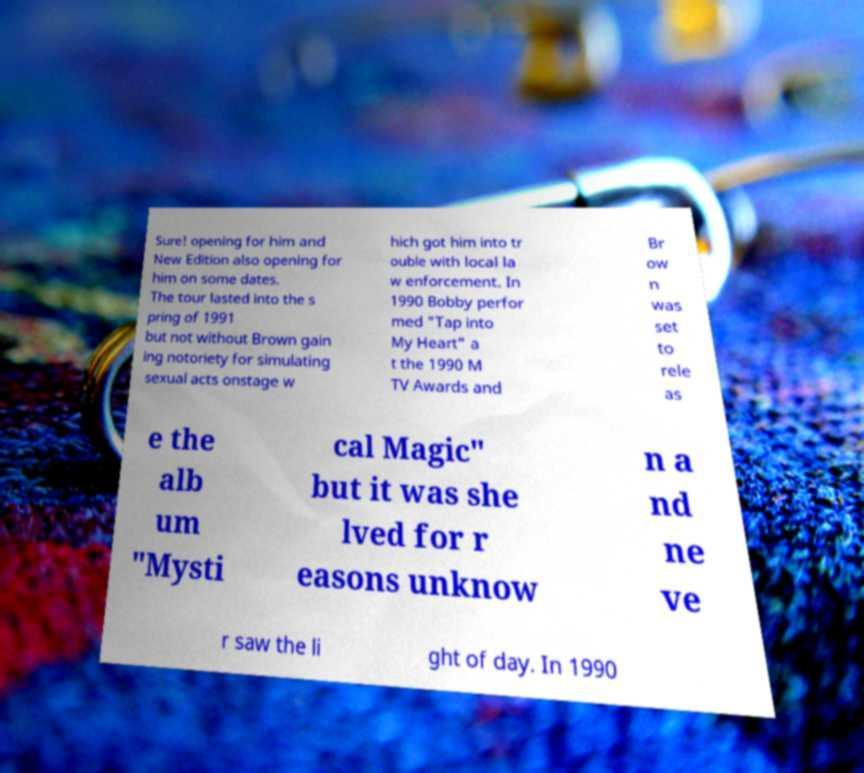Could you assist in decoding the text presented in this image and type it out clearly? Sure! opening for him and New Edition also opening for him on some dates. The tour lasted into the s pring of 1991 but not without Brown gain ing notoriety for simulating sexual acts onstage w hich got him into tr ouble with local la w enforcement. In 1990 Bobby perfor med "Tap into My Heart" a t the 1990 M TV Awards and Br ow n was set to rele as e the alb um "Mysti cal Magic" but it was she lved for r easons unknow n a nd ne ve r saw the li ght of day. In 1990 